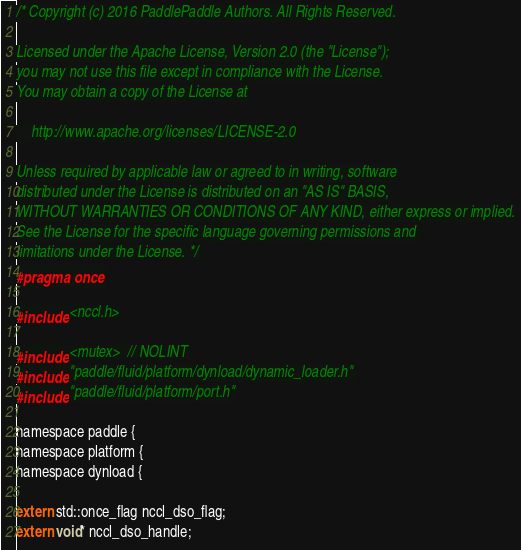<code> <loc_0><loc_0><loc_500><loc_500><_C_>/* Copyright (c) 2016 PaddlePaddle Authors. All Rights Reserved.

Licensed under the Apache License, Version 2.0 (the "License");
you may not use this file except in compliance with the License.
You may obtain a copy of the License at

    http://www.apache.org/licenses/LICENSE-2.0

Unless required by applicable law or agreed to in writing, software
distributed under the License is distributed on an "AS IS" BASIS,
WITHOUT WARRANTIES OR CONDITIONS OF ANY KIND, either express or implied.
See the License for the specific language governing permissions and
limitations under the License. */
#pragma once

#include <nccl.h>

#include <mutex>  // NOLINT
#include "paddle/fluid/platform/dynload/dynamic_loader.h"
#include "paddle/fluid/platform/port.h"

namespace paddle {
namespace platform {
namespace dynload {

extern std::once_flag nccl_dso_flag;
extern void* nccl_dso_handle;
</code> 